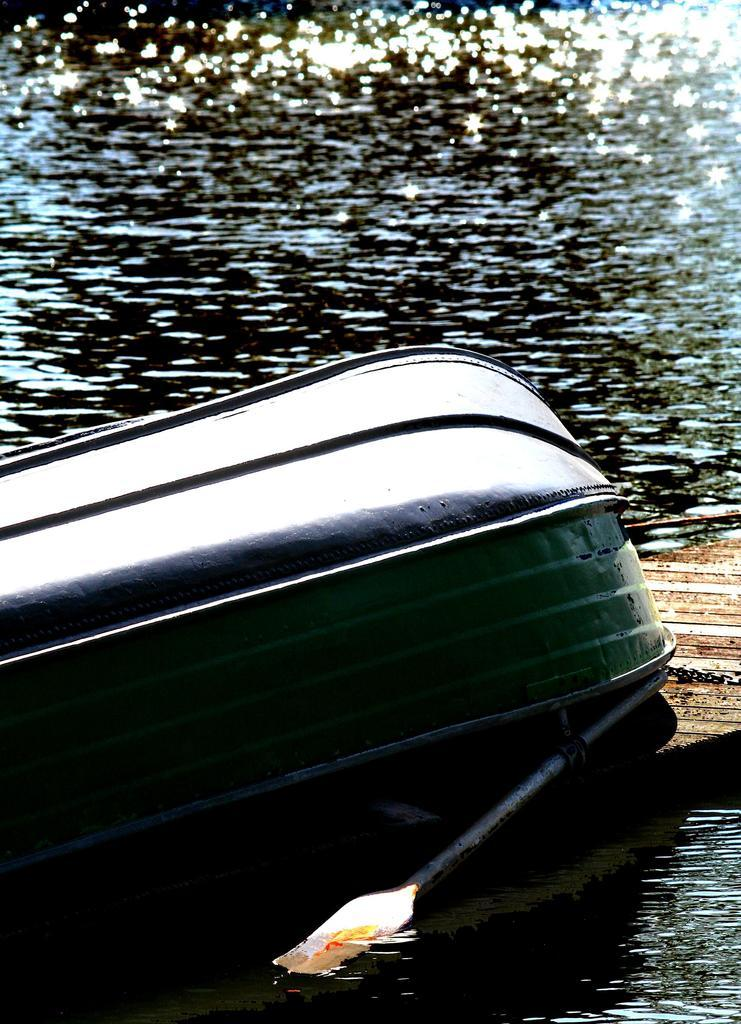What is the setting of the image? The image is an outside view. What can be seen on the water in the image? There is a boat on the water in the image. Who is operating the boat in the image? There is a rower at the bottom of the image. How many drains can be seen in the image? There are no drains present in the image; it features a boat on the water with a rower. What type of order is being followed by the giants in the image? There are no giants present in the image, so there is no order being followed by them. 